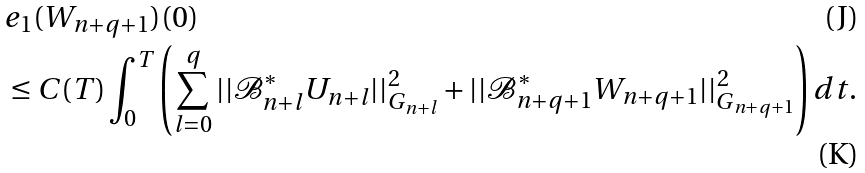Convert formula to latex. <formula><loc_0><loc_0><loc_500><loc_500>& e _ { 1 } ( W _ { n + q + 1 } ) ( 0 ) \\ & \leq C ( T ) \int _ { 0 } ^ { T } \left ( \sum _ { l = 0 } ^ { q } | | \mathcal { B } _ { n + l } ^ { \ast } U _ { n + l } | | _ { G _ { n + l } } ^ { 2 } + | | \mathcal { B } _ { n + q + 1 } ^ { \ast } W _ { n + q + 1 } | | _ { G _ { n + q + 1 } } ^ { 2 } \right ) d t .</formula> 